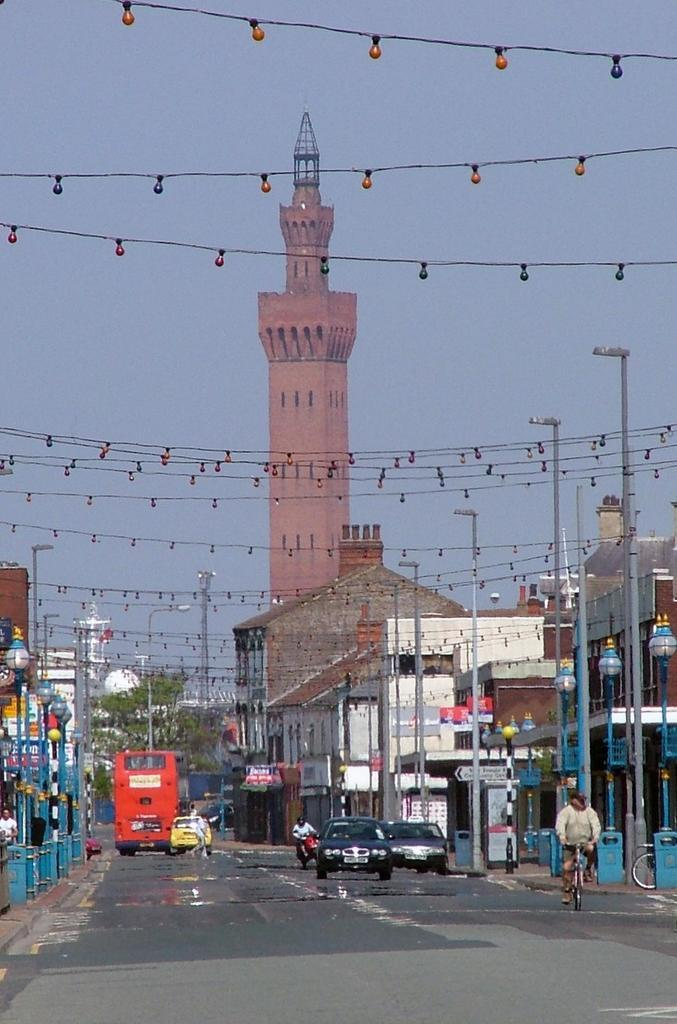What is happening on the road in the image? There are vehicles on the road in the image. What can be seen on both sides of the road? Poles and buildings are visible on both sides of the road. What is visible at the top of the image? The sky is visible at the top of the image, and lights are also present. What is the name of the insect that can be seen flying near the lights in the image? There are no insects present in the image, so it is not possible to determine the name of any insect. 